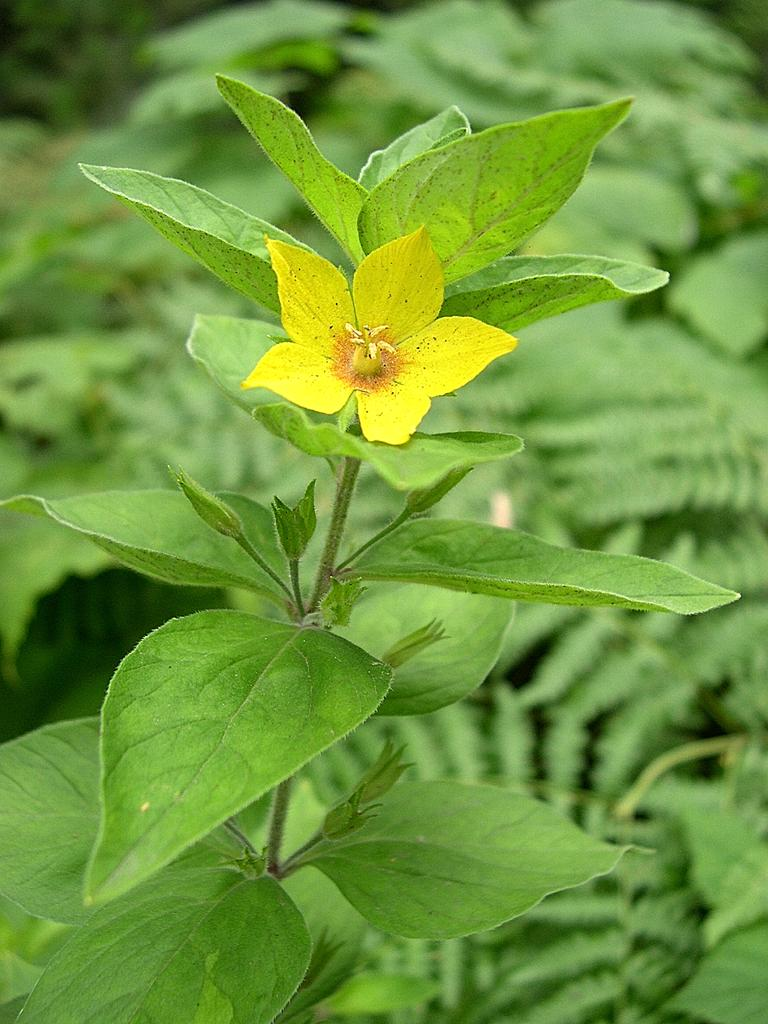What type of plant life is visible in the image? There are buds, a flower, and leaves on a stem in the image. Can you describe the background of the image? The background of the image includes leaves, and it is blurry. Where is the mailbox located in the image? There is no mailbox present in the image. What type of development can be seen in the image? There is no development or construction visible in the image; it primarily features plant life. 